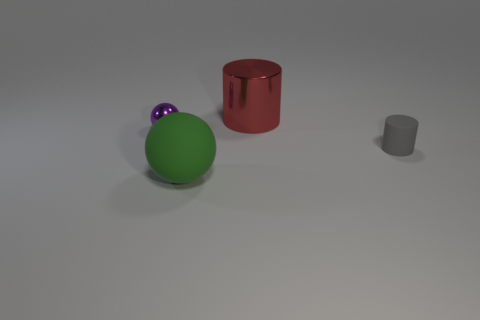Are there any cylinders that are behind the cylinder behind the purple metal ball?
Your answer should be compact. No. There is another thing that is the same size as the purple metal object; what is its color?
Your answer should be compact. Gray. What number of things are matte things or red things?
Provide a short and direct response. 3. There is a thing that is behind the thing on the left side of the sphere that is in front of the gray cylinder; how big is it?
Provide a short and direct response. Large. What number of shiny things are the same color as the tiny matte thing?
Make the answer very short. 0. What number of tiny gray objects are made of the same material as the small purple sphere?
Offer a terse response. 0. How many things are either small rubber things or objects that are behind the gray object?
Offer a very short reply. 3. There is a metal object behind the thing that is left of the matte object that is on the left side of the big red metallic object; what is its color?
Your answer should be compact. Red. What is the size of the thing right of the big metallic cylinder?
Make the answer very short. Small. How many large objects are green matte things or cylinders?
Your answer should be compact. 2. 